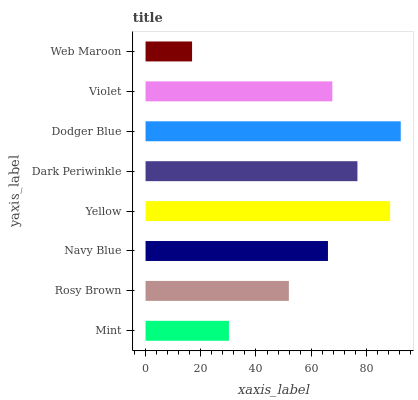Is Web Maroon the minimum?
Answer yes or no. Yes. Is Dodger Blue the maximum?
Answer yes or no. Yes. Is Rosy Brown the minimum?
Answer yes or no. No. Is Rosy Brown the maximum?
Answer yes or no. No. Is Rosy Brown greater than Mint?
Answer yes or no. Yes. Is Mint less than Rosy Brown?
Answer yes or no. Yes. Is Mint greater than Rosy Brown?
Answer yes or no. No. Is Rosy Brown less than Mint?
Answer yes or no. No. Is Violet the high median?
Answer yes or no. Yes. Is Navy Blue the low median?
Answer yes or no. Yes. Is Dodger Blue the high median?
Answer yes or no. No. Is Web Maroon the low median?
Answer yes or no. No. 